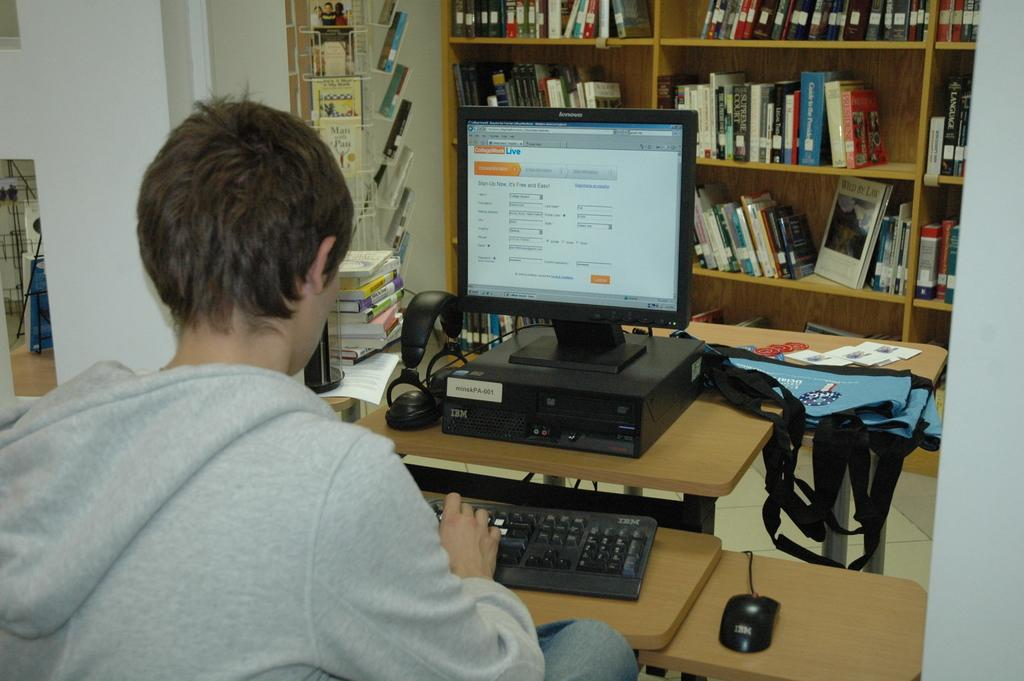What is the boy in the image doing? The boy is seated and typing on a keyboard. What device is the boy using to type? There is a monitor in the image, which suggests that the boy is using a computer. What other items are present on the desk? There is a mouse, headphones, book stands with books, and a hand carry bag on the table in the image. What might the boy be using the headphones for? The headphones could be used for listening to audio, such as music or a video, while working on the computer. What type of locket can be seen around the boy's neck in the image? There is no locket visible around the boy's neck in the image. How many snails can be seen crawling on the keyboard in the image? There are no snails present in the image, and therefore none can be seen crawling on the keyboard. 